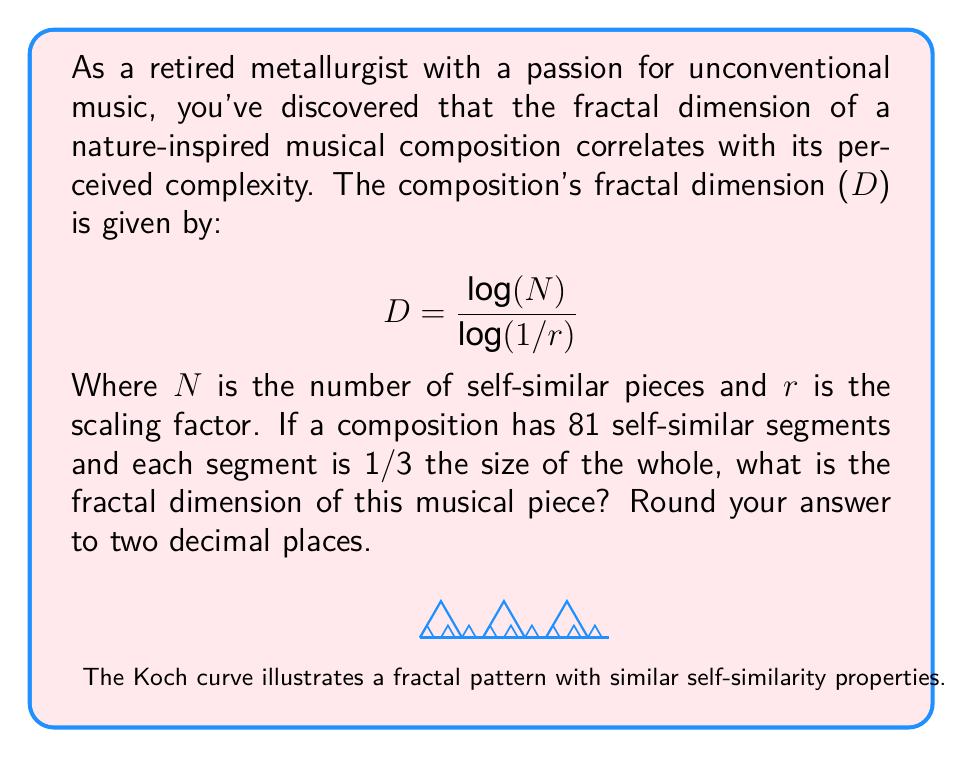What is the answer to this math problem? Let's approach this step-by-step:

1) We are given the formula for fractal dimension:

   $$D = \frac{\log(N)}{\log(1/r)}$$

2) We know that:
   - N = 81 (number of self-similar pieces)
   - r = 1/3 (each segment is 1/3 the size of the whole)

3) Let's substitute these values into the formula:

   $$D = \frac{\log(81)}{\log(1/(1/3))}$$

4) Simplify the denominator:
   $$D = \frac{\log(81)}{\log(3)}$$

5) Now, let's calculate this:
   
   $$D = \frac{\log(81)}{\log(3)} = \frac{4.39444915467}{1.09861228867} = 4$$

6) The question asks for the answer rounded to two decimal places, but in this case, the result is exactly 4.

The fractal dimension of 4 indicates a highly complex structure, which aligns with the intricate nature of fractal-inspired musical compositions.
Answer: 4.00 